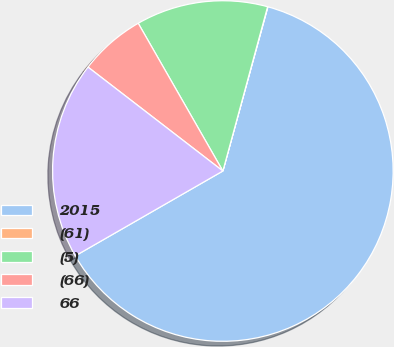Convert chart. <chart><loc_0><loc_0><loc_500><loc_500><pie_chart><fcel>2015<fcel>(61)<fcel>(5)<fcel>(66)<fcel>66<nl><fcel>62.43%<fcel>0.03%<fcel>12.51%<fcel>6.27%<fcel>18.75%<nl></chart> 